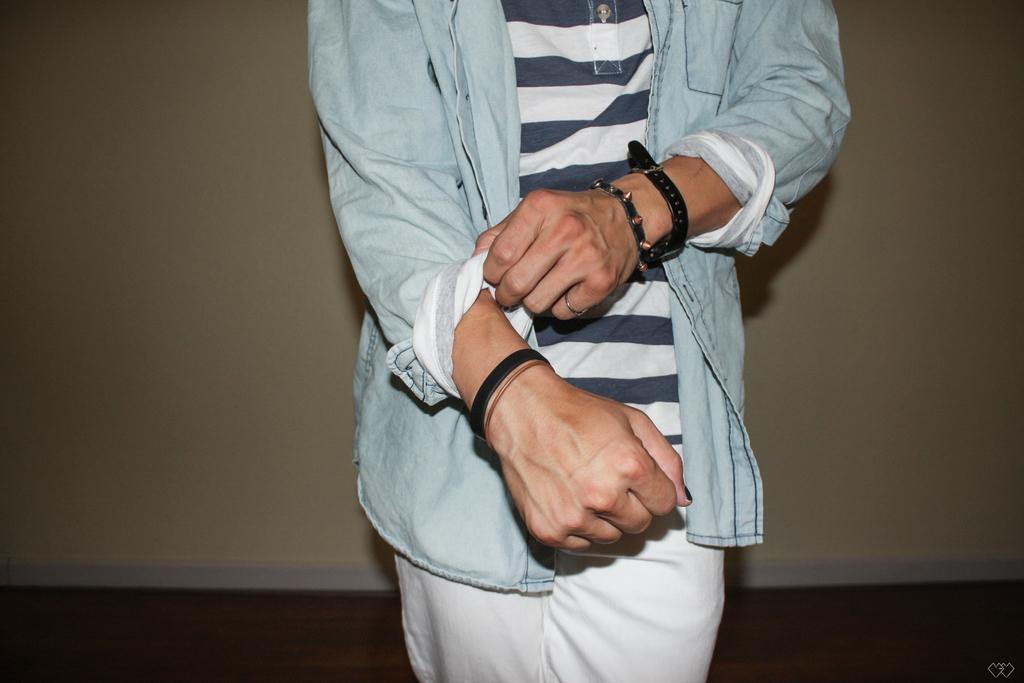Please provide a concise description of this image. In this image I can see a person standing and wearing white and blue color dress. Person is wearing bands. The wall is in cream wall. 